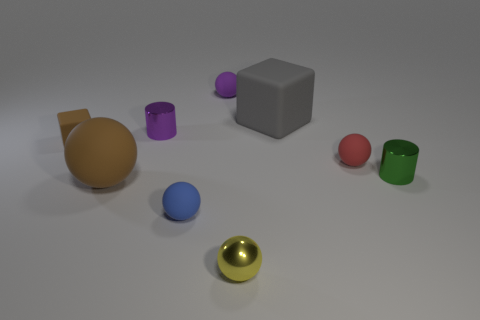Are the tiny cylinder behind the green thing and the big thing behind the red rubber ball made of the same material?
Provide a succinct answer. No. What shape is the tiny yellow thing that is made of the same material as the tiny green cylinder?
Your answer should be compact. Sphere. Is there anything else that has the same color as the large rubber block?
Make the answer very short. No. How many small green matte balls are there?
Offer a terse response. 0. What material is the tiny sphere that is right of the metallic thing in front of the tiny green thing?
Offer a terse response. Rubber. The small metallic sphere right of the brown thing in front of the matte cube to the left of the tiny purple metal object is what color?
Keep it short and to the point. Yellow. Is the shiny ball the same color as the large rubber ball?
Give a very brief answer. No. What number of green shiny cylinders have the same size as the purple shiny thing?
Provide a short and direct response. 1. Is the number of purple cylinders to the left of the brown sphere greater than the number of tiny rubber spheres that are right of the tiny metallic ball?
Give a very brief answer. No. There is a rubber ball that is right of the cube that is on the right side of the tiny purple matte object; what is its color?
Your answer should be very brief. Red. 